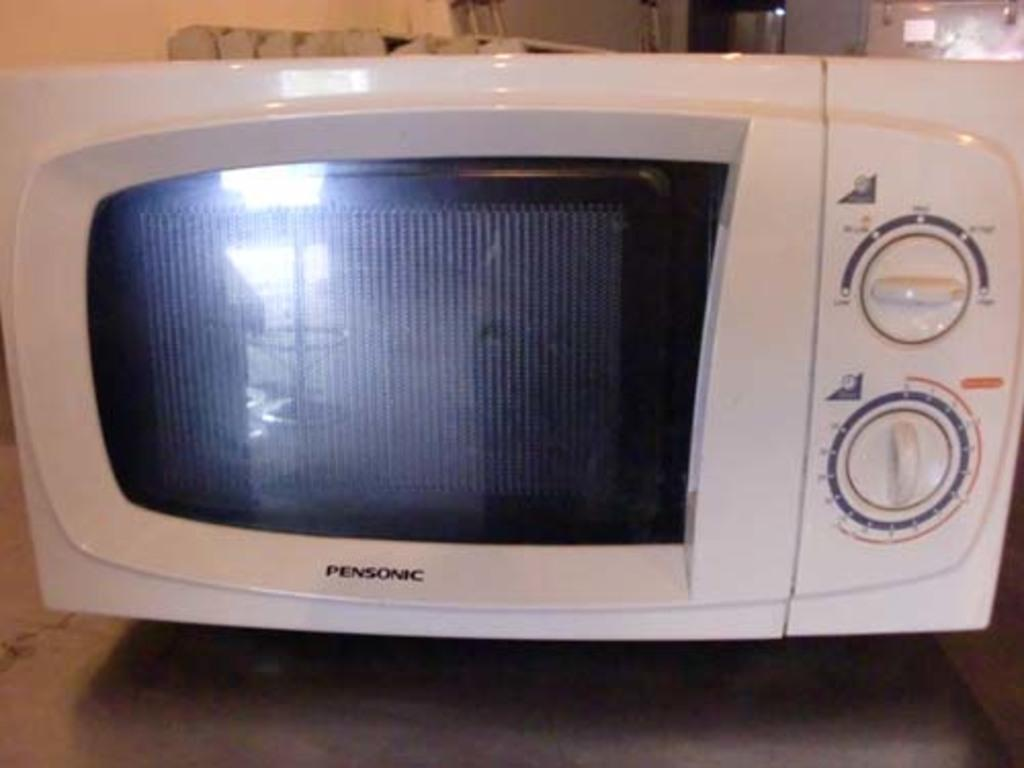What appliance is visible in the image? There is a microwave oven oven in the image. What features can be seen on the microwave oven? The microwave oven has two knobs. Where is the microwave oven located in the image? The microwave oven is placed on a table. What is the income of the person who owns the microwave oven in the image? There is no information about the income of the person who owns the microwave oven in the image. 